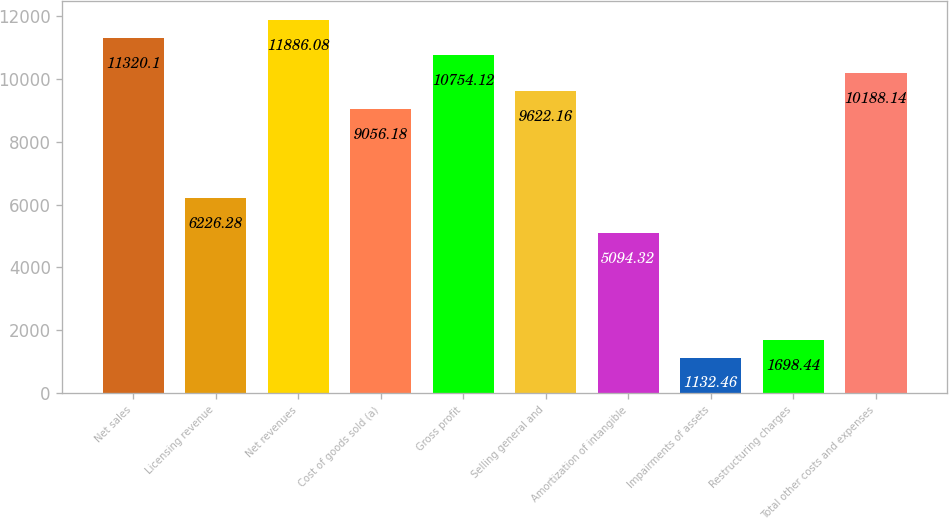Convert chart. <chart><loc_0><loc_0><loc_500><loc_500><bar_chart><fcel>Net sales<fcel>Licensing revenue<fcel>Net revenues<fcel>Cost of goods sold (a)<fcel>Gross profit<fcel>Selling general and<fcel>Amortization of intangible<fcel>Impairments of assets<fcel>Restructuring charges<fcel>Total other costs and expenses<nl><fcel>11320.1<fcel>6226.28<fcel>11886.1<fcel>9056.18<fcel>10754.1<fcel>9622.16<fcel>5094.32<fcel>1132.46<fcel>1698.44<fcel>10188.1<nl></chart> 